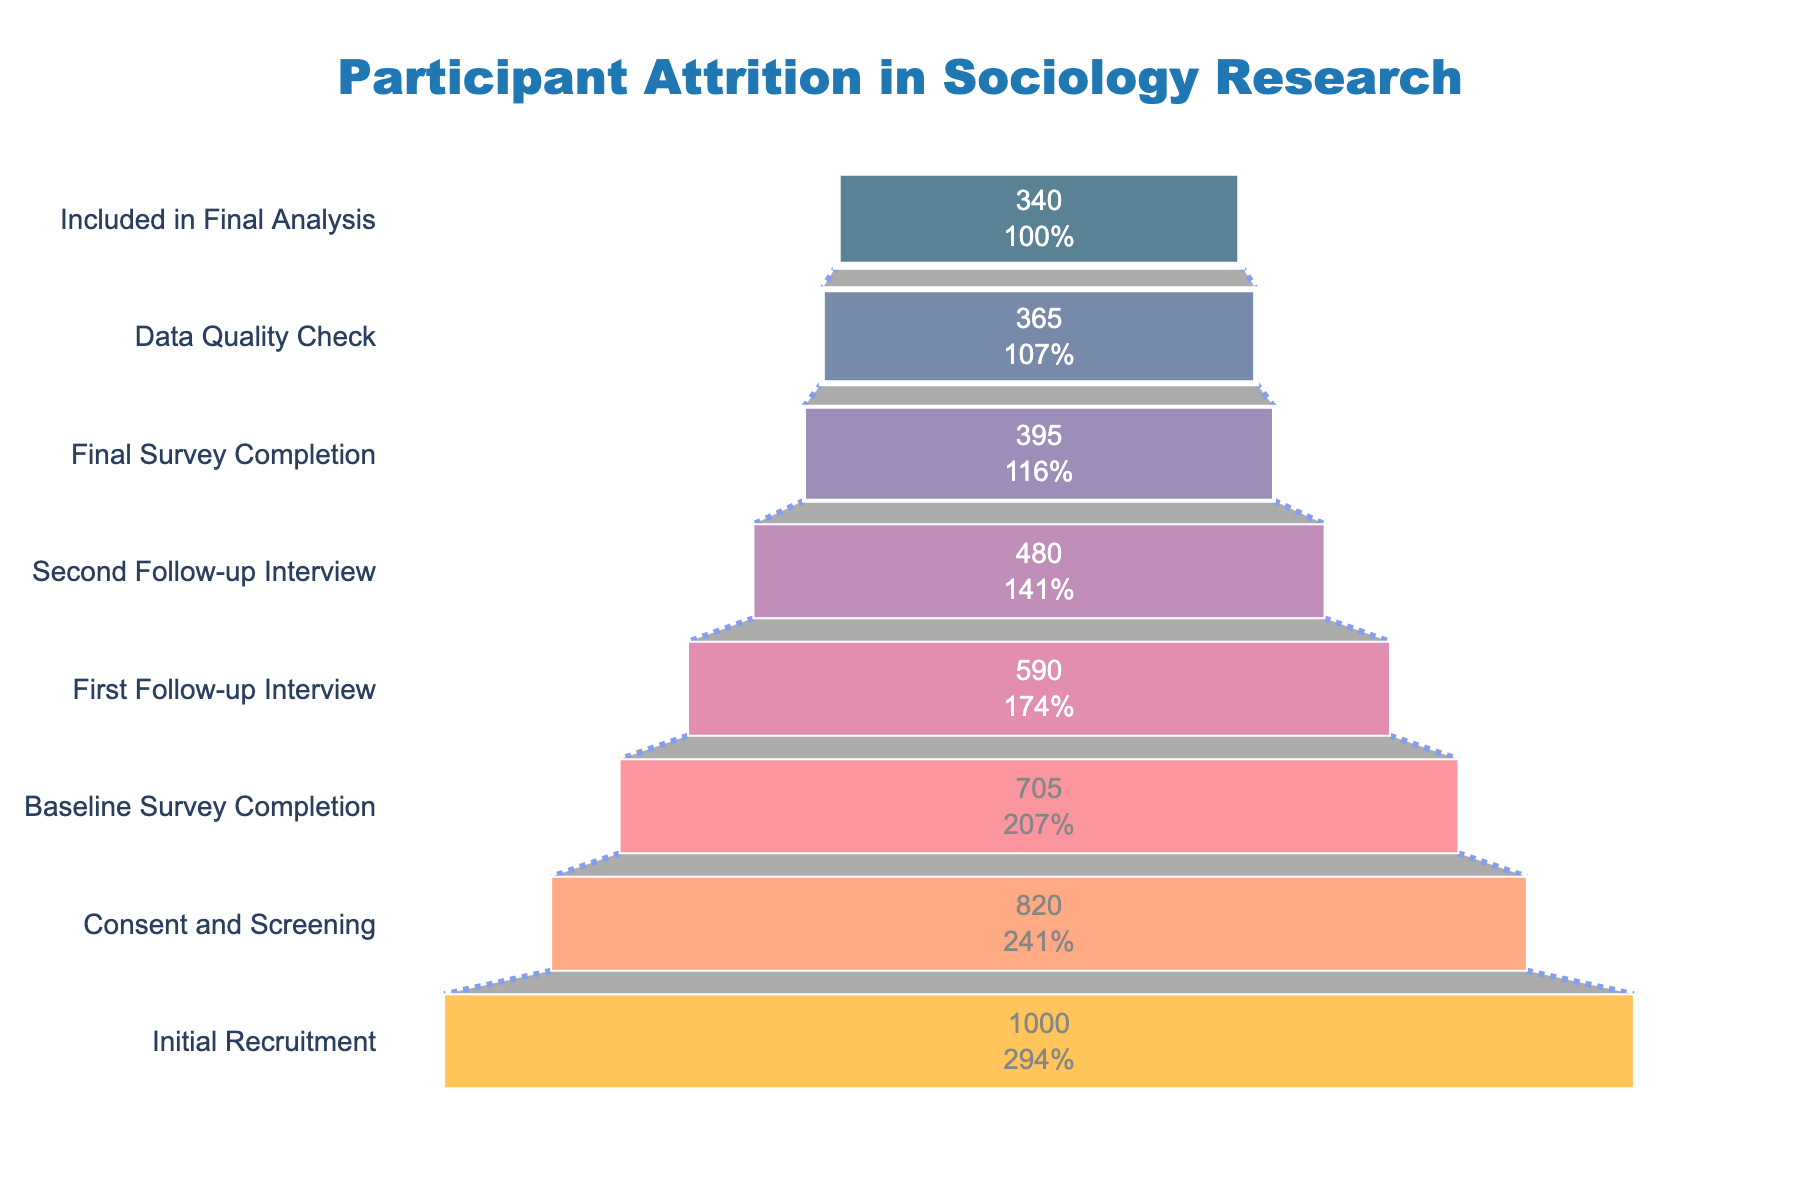What is the title of the chart? The title of the chart is usually found at the top and serves as a descriptive label. In this case, the title "Participant Attrition in Sociology Research" is prominently displayed.
Answer: Participant Attrition in Sociology Research How many participants were included in the initial recruitment stage? By looking at the first (or technically the last) bar in the funnel chart, we can see that the number of participants in the "Initial Recruitment" stage is labeled.
Answer: 1000 What percentage of participants remained from the initial recruitment to the consent and screening stage? First, identify the number of participants at both stages: 1000 at Initial Recruitment and 820 at Consent and Screening. Then, calculate the percentage as (820/1000) * 100.
Answer: 82% How many participants completed the final survey? Locate the stage named "Final Survey Completion" on the chart and read the corresponding number of participants.
Answer: 395 By how many participants did the count drop from the first follow-up interview to the final survey completion? Identify the number of participants at both stages: 590 at First Follow-up Interview and 395 at Final Survey Completion. Subtract the latter from the former (590 - 395).
Answer: 195 Which stage saw the largest drop in participant numbers? Compare the drop in participants between each consecutive stage to find the largest drop. Notably, the drop from Initial Recruitment (1000) to Consent and Screening (820) is the biggest. Calculate the difference: 1000 - 820.
Answer: Initial Recruitment to Consent and Screening (180 participants) What is the difference in participant numbers between the final survey completion and those included in the final analysis stage? Locate the participant counts for both stages: 395 at Final Survey Completion and 340 at Included in Final Analysis. Subtract the latter from the former (395 - 340).
Answer: 55 What percentage of participants who completed the baseline survey also completed the final survey? First, identify the number of participants at both stages: 705 at Baseline Survey Completion and 395 at Final Survey Completion. Calculate the percentage as (395/705) * 100.
Answer: Approximately 56% 